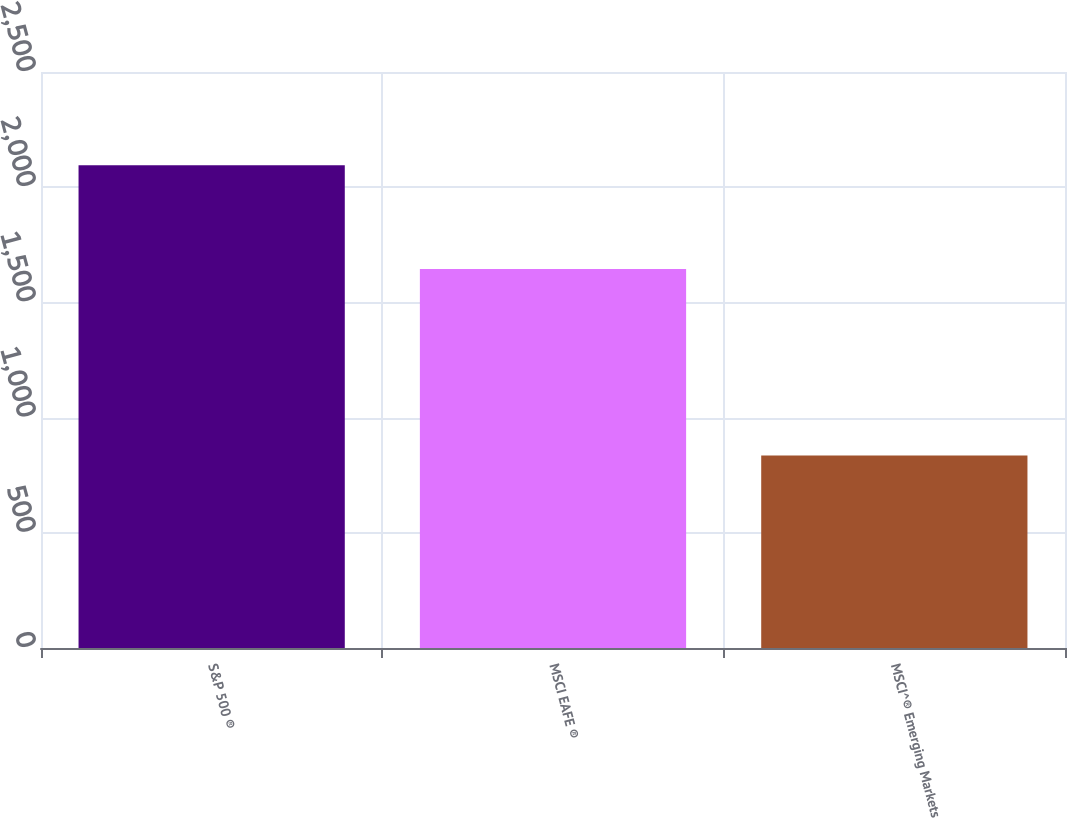Convert chart. <chart><loc_0><loc_0><loc_500><loc_500><bar_chart><fcel>S&P 500 ®<fcel>MSCI EAFE ®<fcel>MSCI^® Emerging Markets<nl><fcel>2095<fcel>1645<fcel>835<nl></chart> 